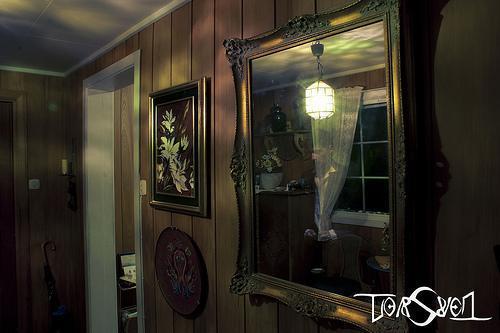How many items are hanging on the wall?
Give a very brief answer. 3. How many partial or whole window panes are reflected in the mirror?
Give a very brief answer. 6. 